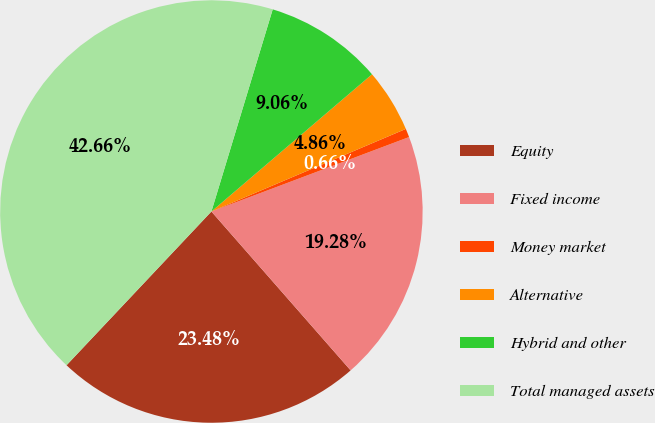Convert chart to OTSL. <chart><loc_0><loc_0><loc_500><loc_500><pie_chart><fcel>Equity<fcel>Fixed income<fcel>Money market<fcel>Alternative<fcel>Hybrid and other<fcel>Total managed assets<nl><fcel>23.48%<fcel>19.28%<fcel>0.66%<fcel>4.86%<fcel>9.06%<fcel>42.66%<nl></chart> 